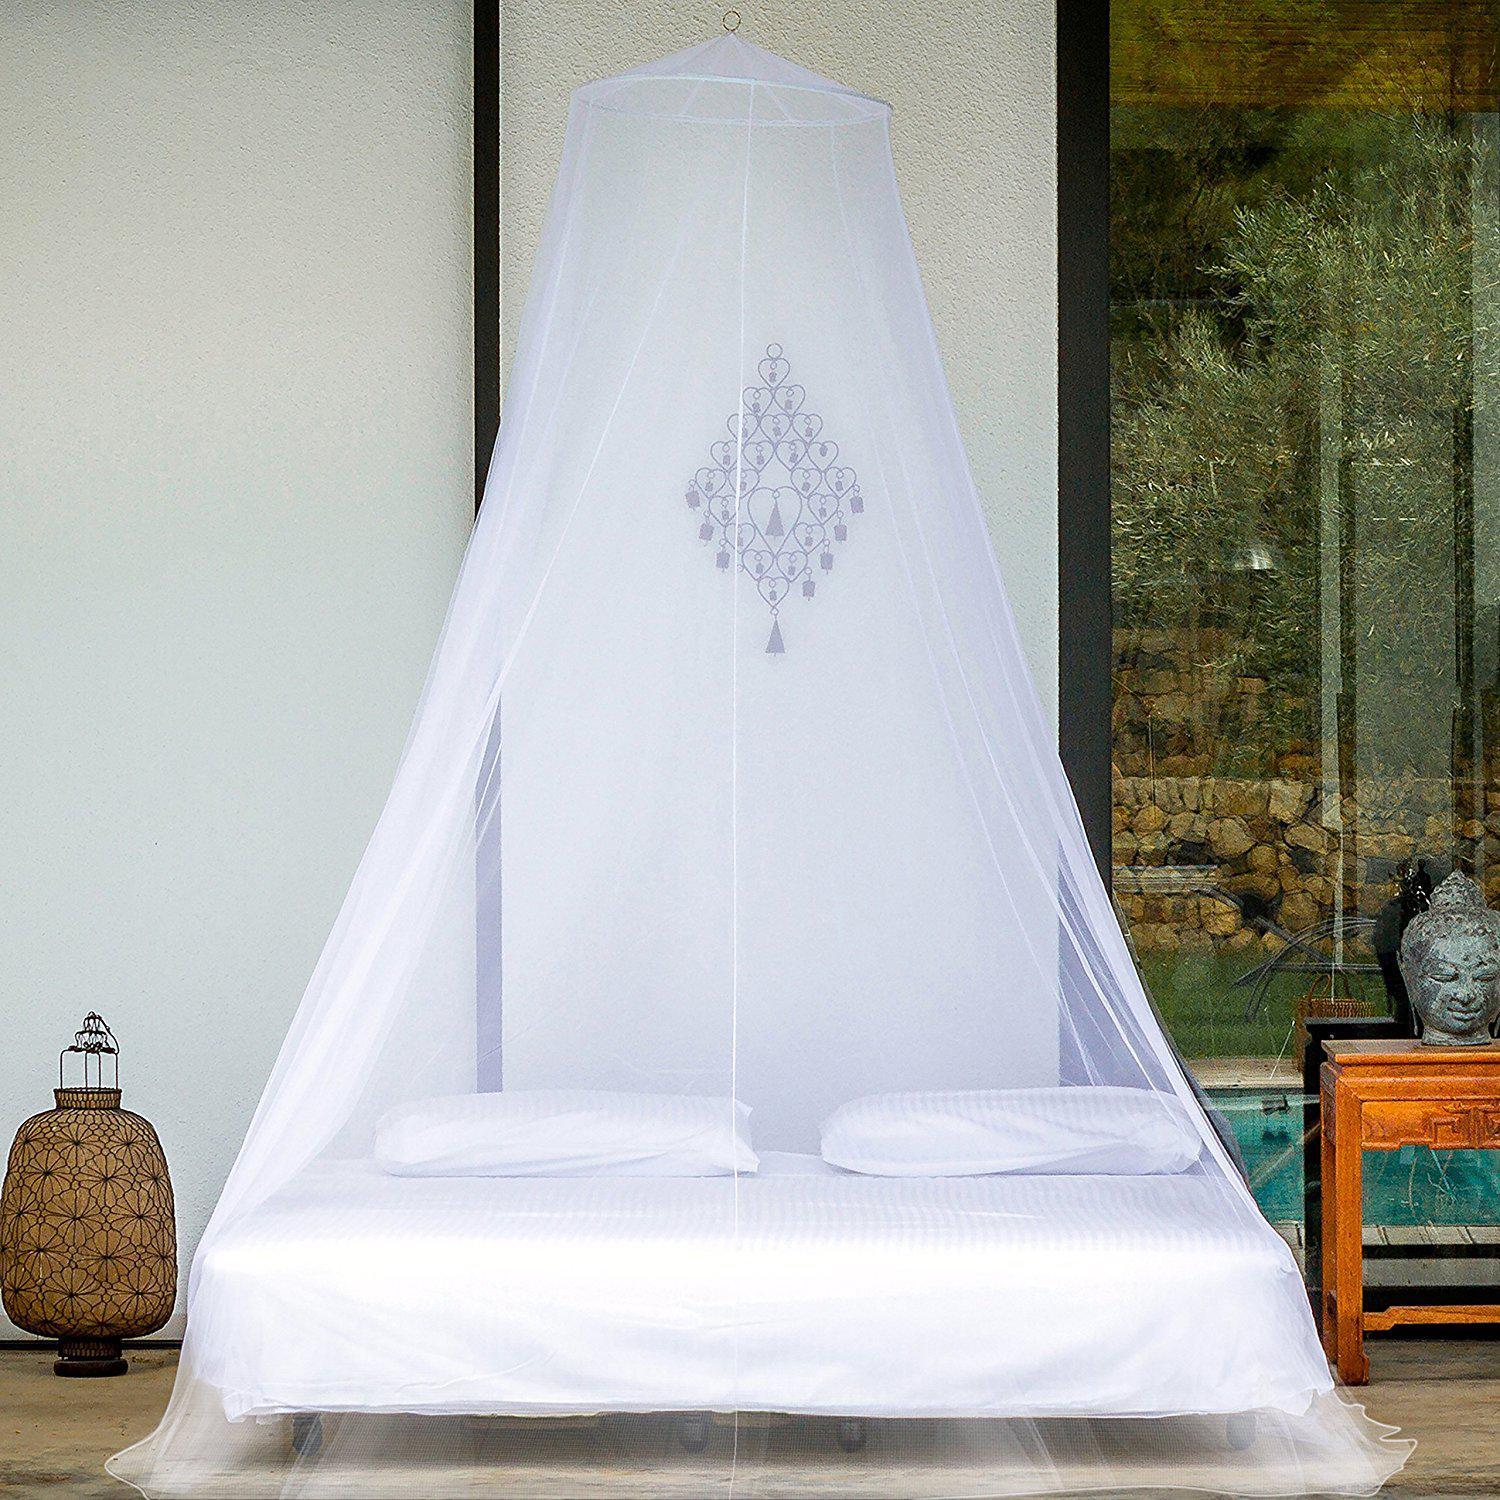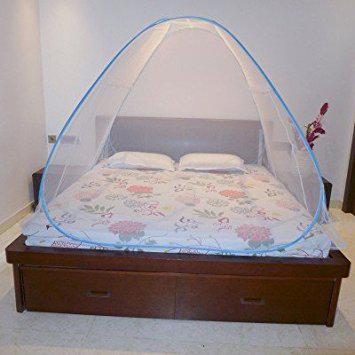The first image is the image on the left, the second image is the image on the right. For the images shown, is this caption "there are two brown pillows in the image on the left" true? Answer yes or no. No. The first image is the image on the left, the second image is the image on the right. Analyze the images presented: Is the assertion "In at least one image, a green and blue case sits in front of a bed canopy." valid? Answer yes or no. No. 